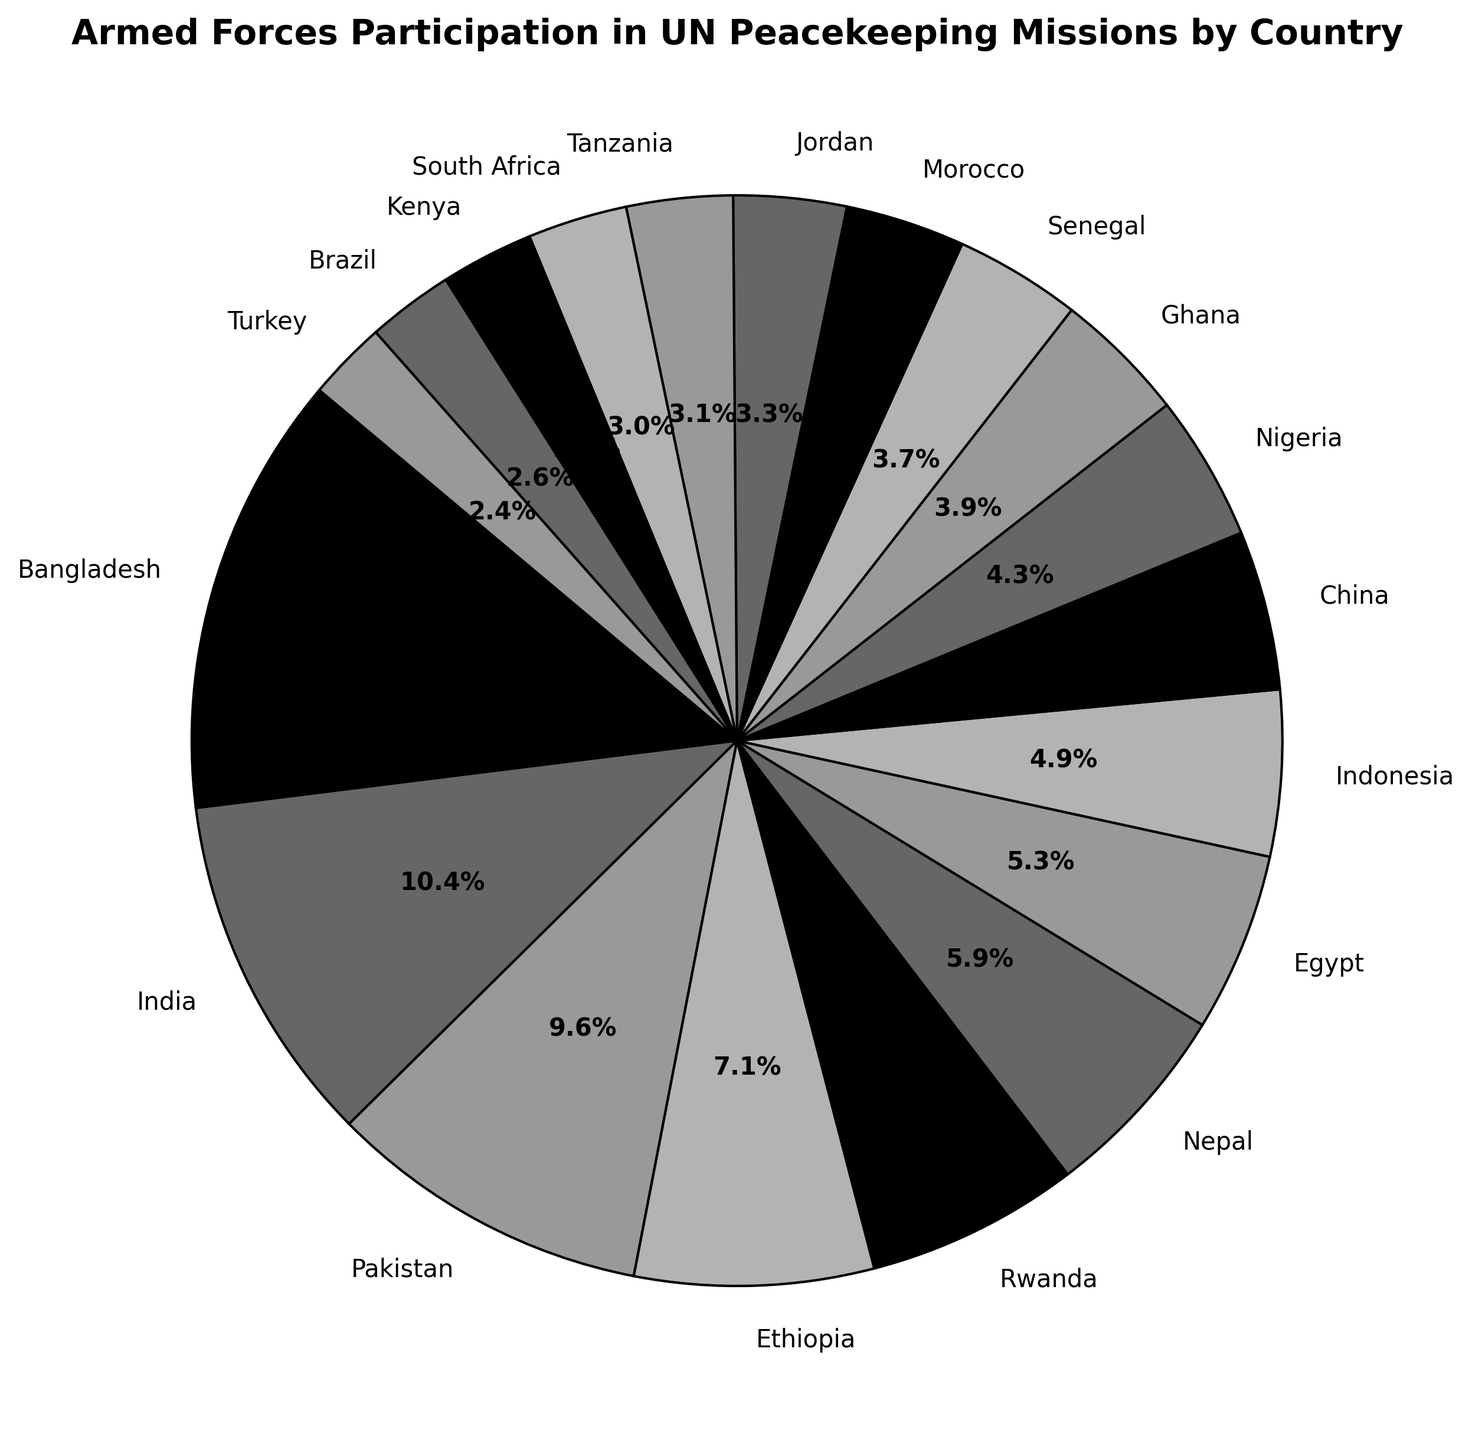Which country has the largest participation in UN Peacekeeping Missions? From the pie chart, the slice representing Bangladesh is the largest. This indicates that Bangladesh has the highest number of personnel participating in the UN Peacekeeping Missions.
Answer: Bangladesh What proportion of personnel does Bangladesh contribute to UN Peacekeeping Missions? In the pie chart, the slice for Bangladesh shows the percentage of 29.1%. This indicates that Bangladesh contributes approximately 29.1% of the total personnel.
Answer: 29.1% Which three countries contribute the least personnel to UN Peacekeeping Missions? By looking at the smallest slices in the pie chart, the least contributions come from Brazil, Turkey, and Kenya.
Answer: Brazil, Turkey, Kenya How does India's participation compare to Pakistan's? By comparing the sizes of the slices for India and Pakistan, it is clear that India has a larger slice than Pakistan. India's participation is therefore greater than Pakistan's.
Answer: India has a greater participation than Pakistan What is the combined total percentage of personnel from Bangladesh, India, and Pakistan? Bangladesh contributes 29.1%, India contributes 23.2%, and Pakistan contributes 21.3%. Their combined percentage is 29.1% + 23.2% + 21.3% = 73.6%.
Answer: 73.6% Which country has a similar contribution to Nigeria in terms of visual slice size? By visually examining the pie chart, the slice size for Indonesia appears similar to that of Nigeria.
Answer: Indonesia How does the combined contribution of Ethiopia and Rwanda compare to Bangladesh? Ethiopia contributes 15.7% and Rwanda contributes 14.0%. Combined, they contribute 15.7% + 14.0% = 29.7%. Bangladesh alone contributes 29.1%. Hence, Ethiopia and Rwanda combined contribute just slightly more than Bangladesh.
Answer: Slightly more What is the average percentage contribution of Nepal, Egypt, and Indonesia? Nepal contributes 13.1%, Egypt 11.8%, and Indonesia 10.9%. The average percentage is (13.1% + 11.8% + 10.9%) / 3 = 11.93%.
Answer: 11.93% Is there any country contributing exactly 10% of the personnel? According to the pie chart, there is no country with a slice indicating a 10% contribution.
Answer: No How does China's participation in UN Peacekeeping Missions compare to Senegal's? Visually inspecting the pie chart, the slice for China is larger than the slice for Senegal, indicating that China has a greater participation.
Answer: China has greater participation than Senegal 